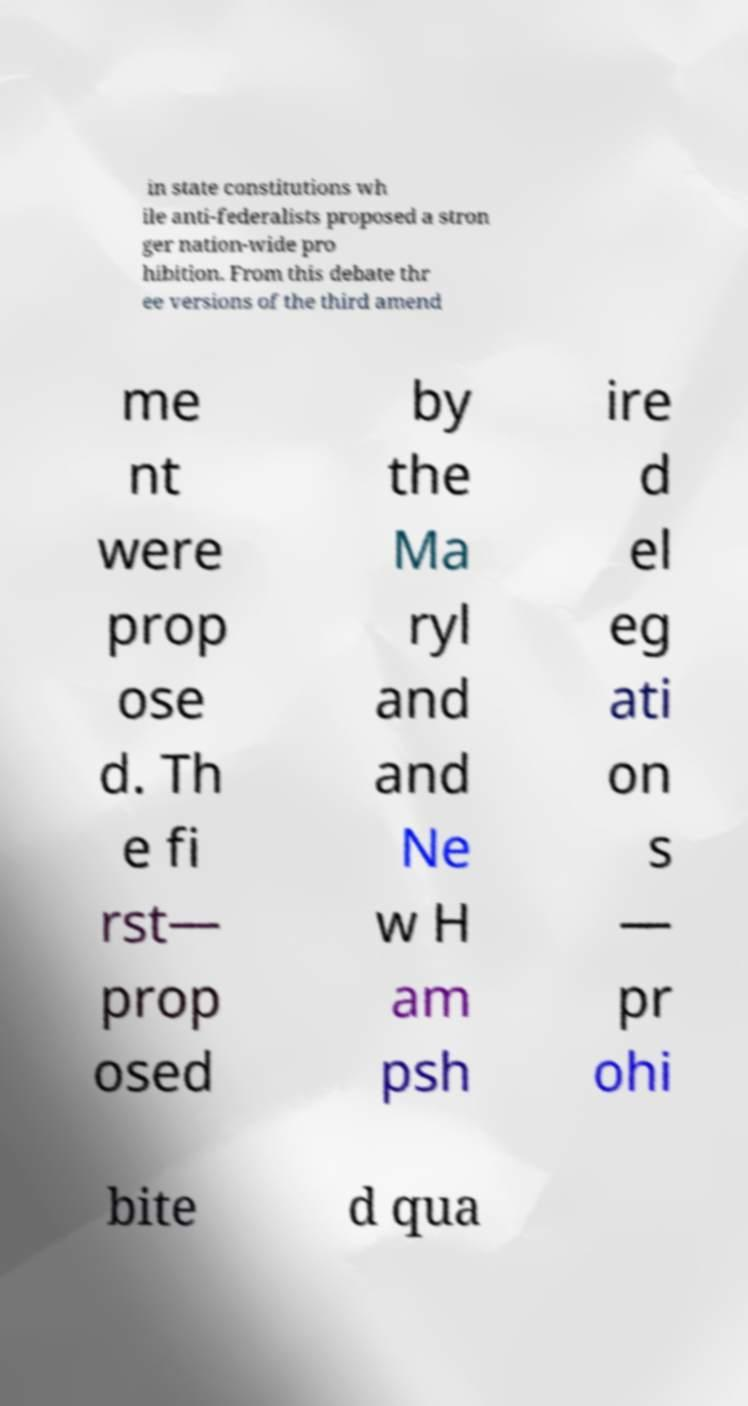Can you accurately transcribe the text from the provided image for me? in state constitutions wh ile anti-federalists proposed a stron ger nation-wide pro hibition. From this debate thr ee versions of the third amend me nt were prop ose d. Th e fi rst— prop osed by the Ma ryl and and Ne w H am psh ire d el eg ati on s — pr ohi bite d qua 